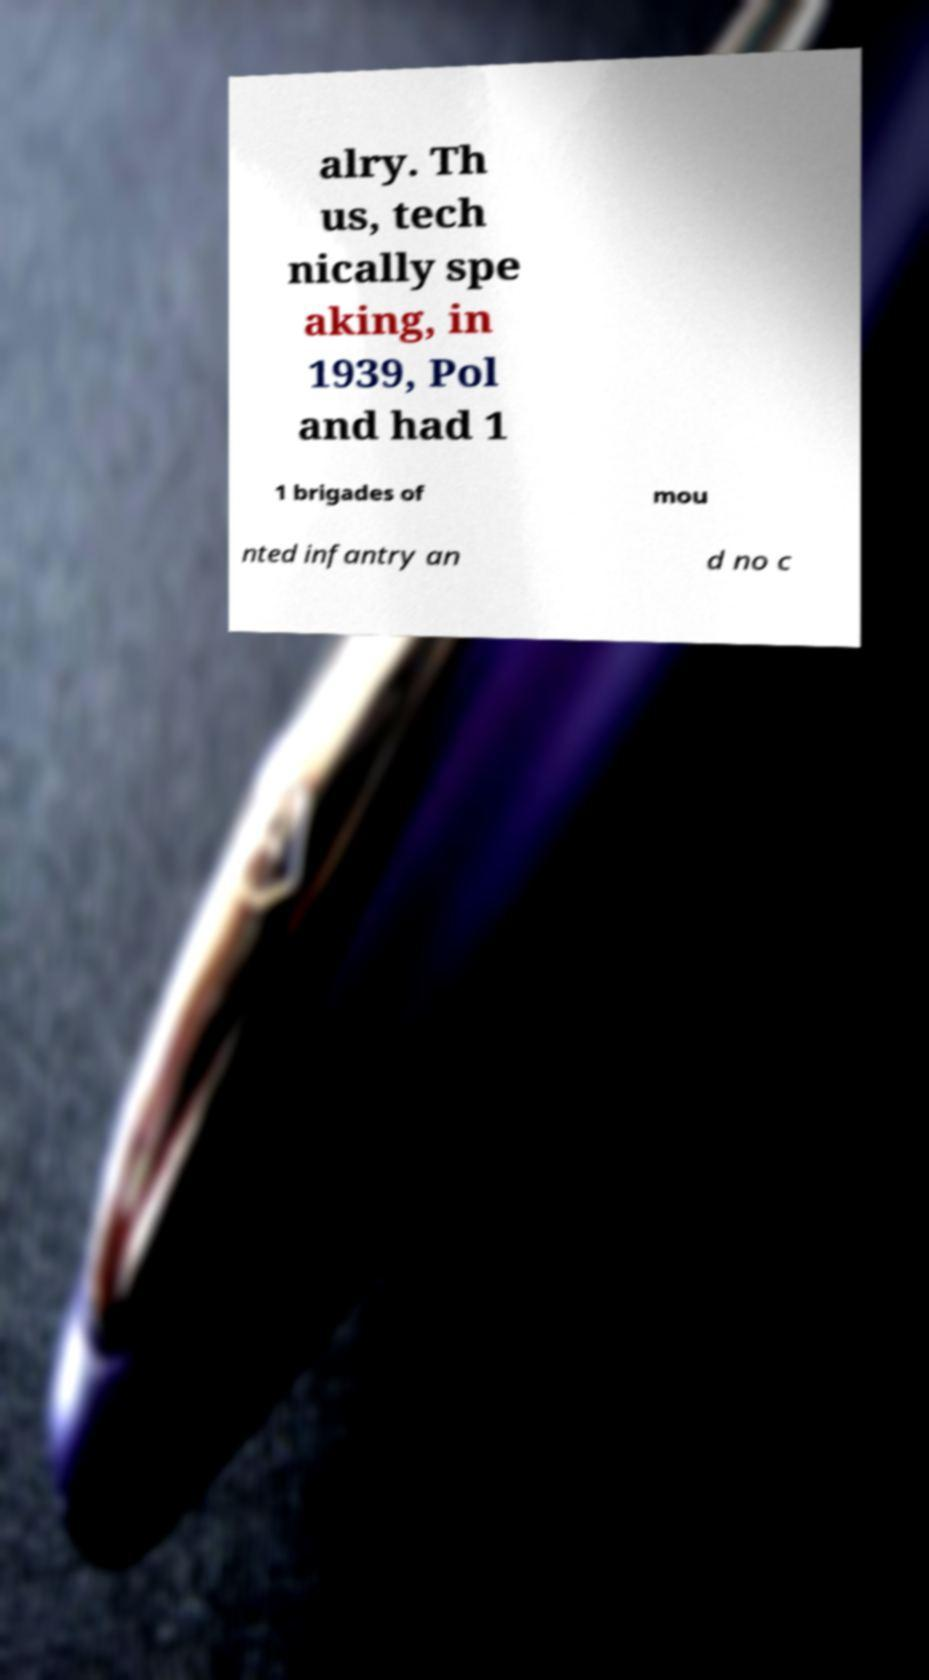Please read and relay the text visible in this image. What does it say? alry. Th us, tech nically spe aking, in 1939, Pol and had 1 1 brigades of mou nted infantry an d no c 